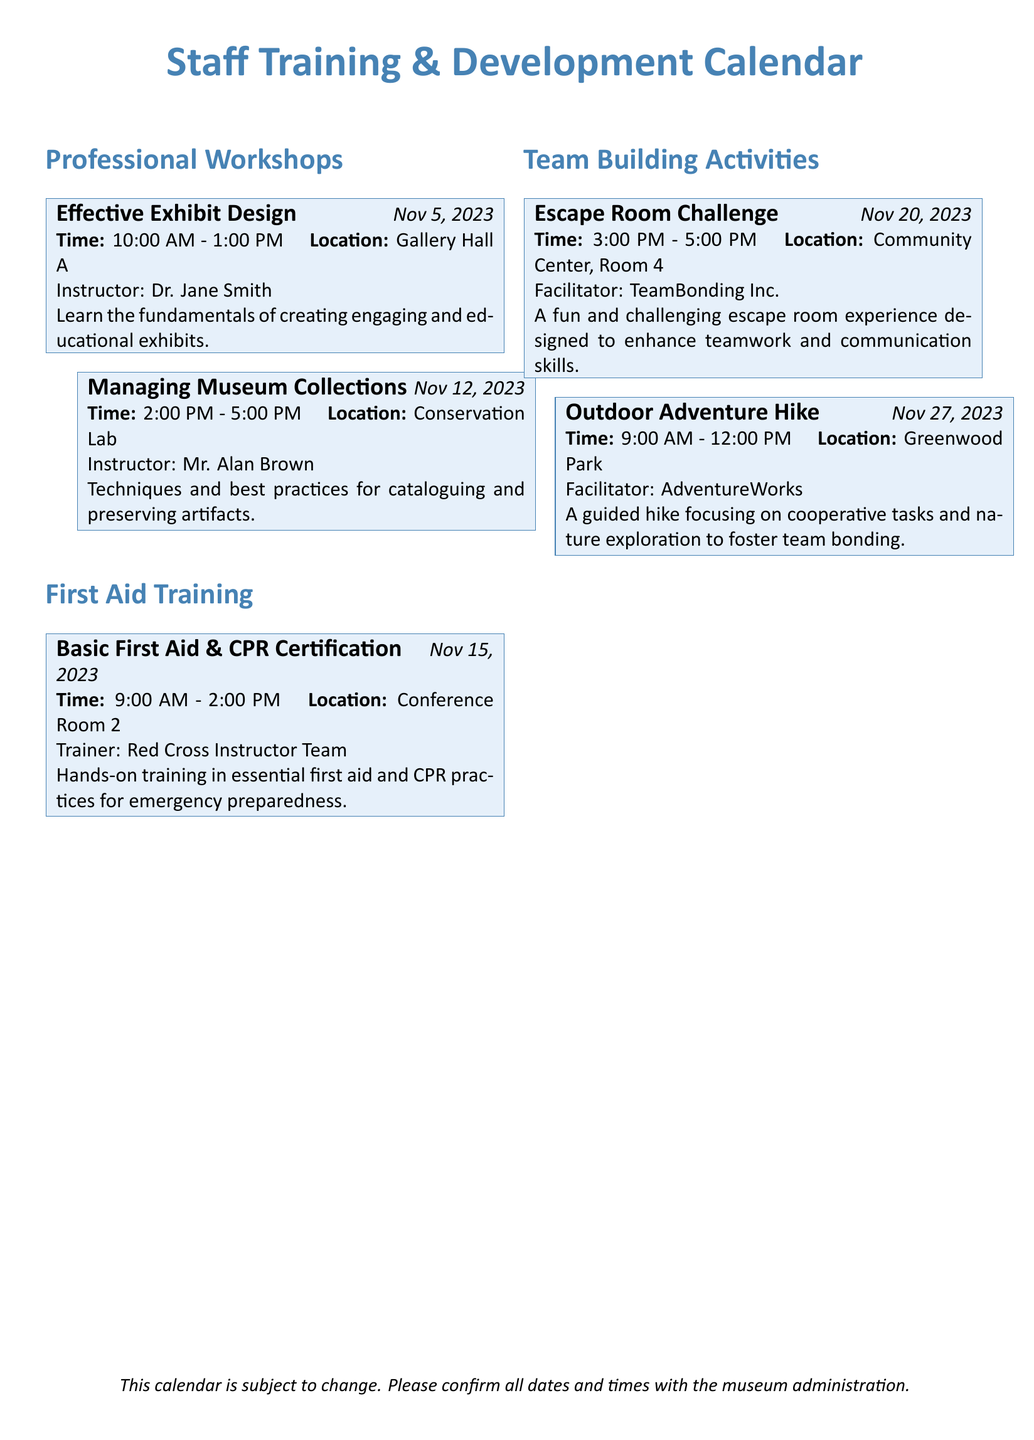What is the date of the Effective Exhibit Design workshop? The date is explicitly stated in the event as November 5, 2023.
Answer: November 5, 2023 Who is the instructor for the Managing Museum Collections workshop? The instructor's name is provided in the details of the workshop.
Answer: Mr. Alan Brown What time does the Basic First Aid & CPR Certification training start? The start time is listed in the training event details.
Answer: 9:00 AM How long is the Escape Room Challenge scheduled to last? The duration can be calculated based on the start and end times provided in the document.
Answer: 2 hours Where is the Outdoor Adventure Hike taking place? The location is mentioned in the event details.
Answer: Greenwood Park What is the primary focus of the Basic First Aid & CPR Certification training? The focus is described in the event details, summarizing the content of the training.
Answer: Essential first aid and CPR practices Which activity is scheduled for November 27, 2023? The date allows us to identify the specific team-building activity from the calendar.
Answer: Outdoor Adventure Hike Who is facilitating the Escape Room Challenge? The facilitator's name is noted in the event details.
Answer: TeamBonding Inc 